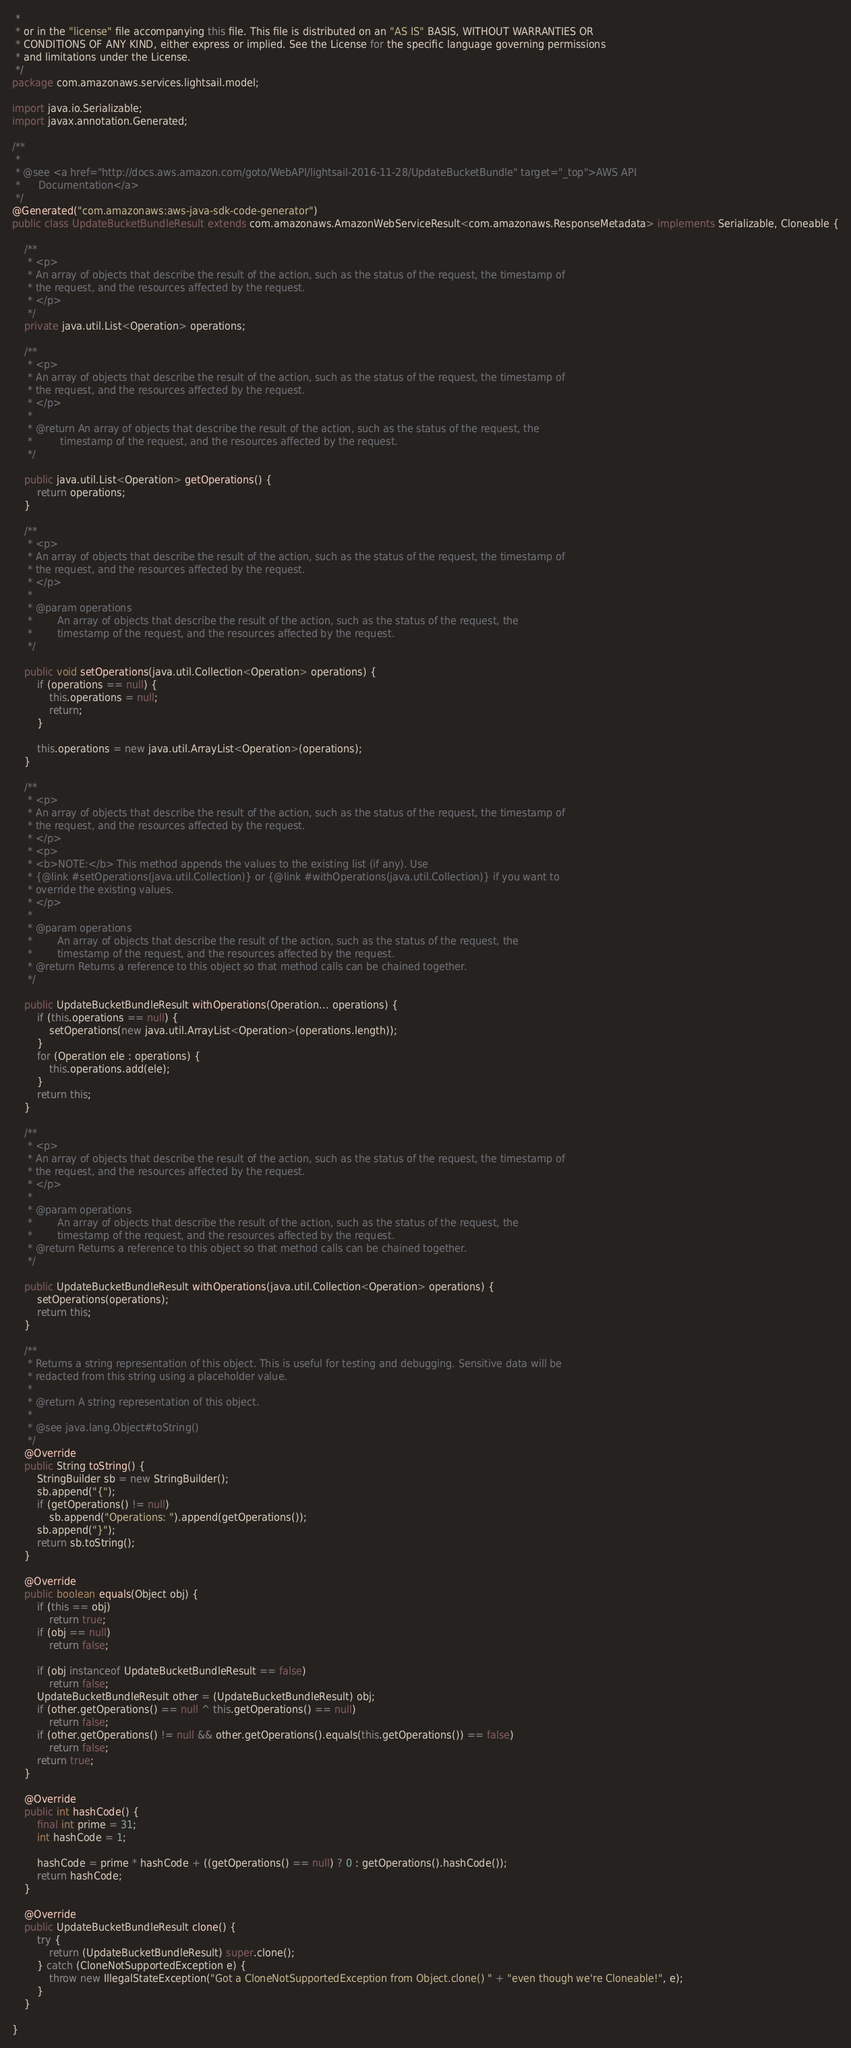<code> <loc_0><loc_0><loc_500><loc_500><_Java_> * 
 * or in the "license" file accompanying this file. This file is distributed on an "AS IS" BASIS, WITHOUT WARRANTIES OR
 * CONDITIONS OF ANY KIND, either express or implied. See the License for the specific language governing permissions
 * and limitations under the License.
 */
package com.amazonaws.services.lightsail.model;

import java.io.Serializable;
import javax.annotation.Generated;

/**
 * 
 * @see <a href="http://docs.aws.amazon.com/goto/WebAPI/lightsail-2016-11-28/UpdateBucketBundle" target="_top">AWS API
 *      Documentation</a>
 */
@Generated("com.amazonaws:aws-java-sdk-code-generator")
public class UpdateBucketBundleResult extends com.amazonaws.AmazonWebServiceResult<com.amazonaws.ResponseMetadata> implements Serializable, Cloneable {

    /**
     * <p>
     * An array of objects that describe the result of the action, such as the status of the request, the timestamp of
     * the request, and the resources affected by the request.
     * </p>
     */
    private java.util.List<Operation> operations;

    /**
     * <p>
     * An array of objects that describe the result of the action, such as the status of the request, the timestamp of
     * the request, and the resources affected by the request.
     * </p>
     * 
     * @return An array of objects that describe the result of the action, such as the status of the request, the
     *         timestamp of the request, and the resources affected by the request.
     */

    public java.util.List<Operation> getOperations() {
        return operations;
    }

    /**
     * <p>
     * An array of objects that describe the result of the action, such as the status of the request, the timestamp of
     * the request, and the resources affected by the request.
     * </p>
     * 
     * @param operations
     *        An array of objects that describe the result of the action, such as the status of the request, the
     *        timestamp of the request, and the resources affected by the request.
     */

    public void setOperations(java.util.Collection<Operation> operations) {
        if (operations == null) {
            this.operations = null;
            return;
        }

        this.operations = new java.util.ArrayList<Operation>(operations);
    }

    /**
     * <p>
     * An array of objects that describe the result of the action, such as the status of the request, the timestamp of
     * the request, and the resources affected by the request.
     * </p>
     * <p>
     * <b>NOTE:</b> This method appends the values to the existing list (if any). Use
     * {@link #setOperations(java.util.Collection)} or {@link #withOperations(java.util.Collection)} if you want to
     * override the existing values.
     * </p>
     * 
     * @param operations
     *        An array of objects that describe the result of the action, such as the status of the request, the
     *        timestamp of the request, and the resources affected by the request.
     * @return Returns a reference to this object so that method calls can be chained together.
     */

    public UpdateBucketBundleResult withOperations(Operation... operations) {
        if (this.operations == null) {
            setOperations(new java.util.ArrayList<Operation>(operations.length));
        }
        for (Operation ele : operations) {
            this.operations.add(ele);
        }
        return this;
    }

    /**
     * <p>
     * An array of objects that describe the result of the action, such as the status of the request, the timestamp of
     * the request, and the resources affected by the request.
     * </p>
     * 
     * @param operations
     *        An array of objects that describe the result of the action, such as the status of the request, the
     *        timestamp of the request, and the resources affected by the request.
     * @return Returns a reference to this object so that method calls can be chained together.
     */

    public UpdateBucketBundleResult withOperations(java.util.Collection<Operation> operations) {
        setOperations(operations);
        return this;
    }

    /**
     * Returns a string representation of this object. This is useful for testing and debugging. Sensitive data will be
     * redacted from this string using a placeholder value.
     *
     * @return A string representation of this object.
     *
     * @see java.lang.Object#toString()
     */
    @Override
    public String toString() {
        StringBuilder sb = new StringBuilder();
        sb.append("{");
        if (getOperations() != null)
            sb.append("Operations: ").append(getOperations());
        sb.append("}");
        return sb.toString();
    }

    @Override
    public boolean equals(Object obj) {
        if (this == obj)
            return true;
        if (obj == null)
            return false;

        if (obj instanceof UpdateBucketBundleResult == false)
            return false;
        UpdateBucketBundleResult other = (UpdateBucketBundleResult) obj;
        if (other.getOperations() == null ^ this.getOperations() == null)
            return false;
        if (other.getOperations() != null && other.getOperations().equals(this.getOperations()) == false)
            return false;
        return true;
    }

    @Override
    public int hashCode() {
        final int prime = 31;
        int hashCode = 1;

        hashCode = prime * hashCode + ((getOperations() == null) ? 0 : getOperations().hashCode());
        return hashCode;
    }

    @Override
    public UpdateBucketBundleResult clone() {
        try {
            return (UpdateBucketBundleResult) super.clone();
        } catch (CloneNotSupportedException e) {
            throw new IllegalStateException("Got a CloneNotSupportedException from Object.clone() " + "even though we're Cloneable!", e);
        }
    }

}
</code> 